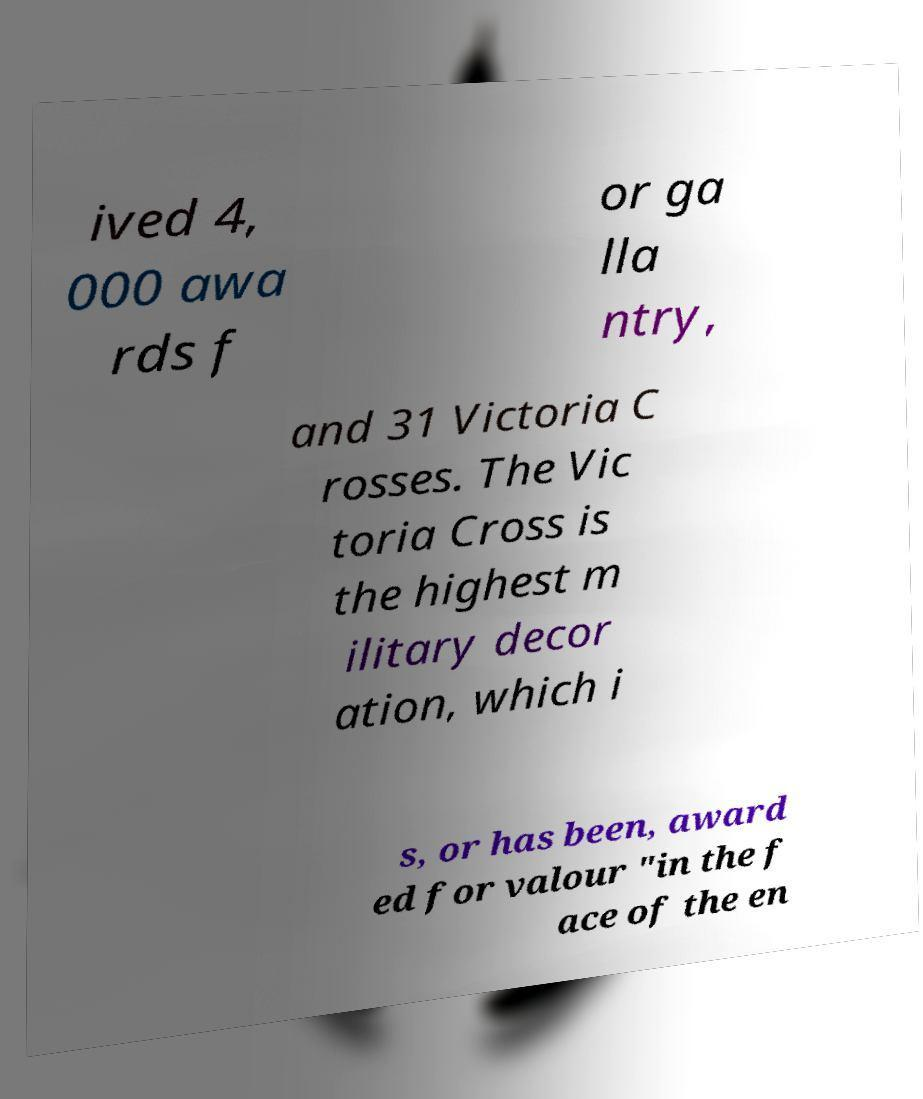Could you assist in decoding the text presented in this image and type it out clearly? ived 4, 000 awa rds f or ga lla ntry, and 31 Victoria C rosses. The Vic toria Cross is the highest m ilitary decor ation, which i s, or has been, award ed for valour "in the f ace of the en 